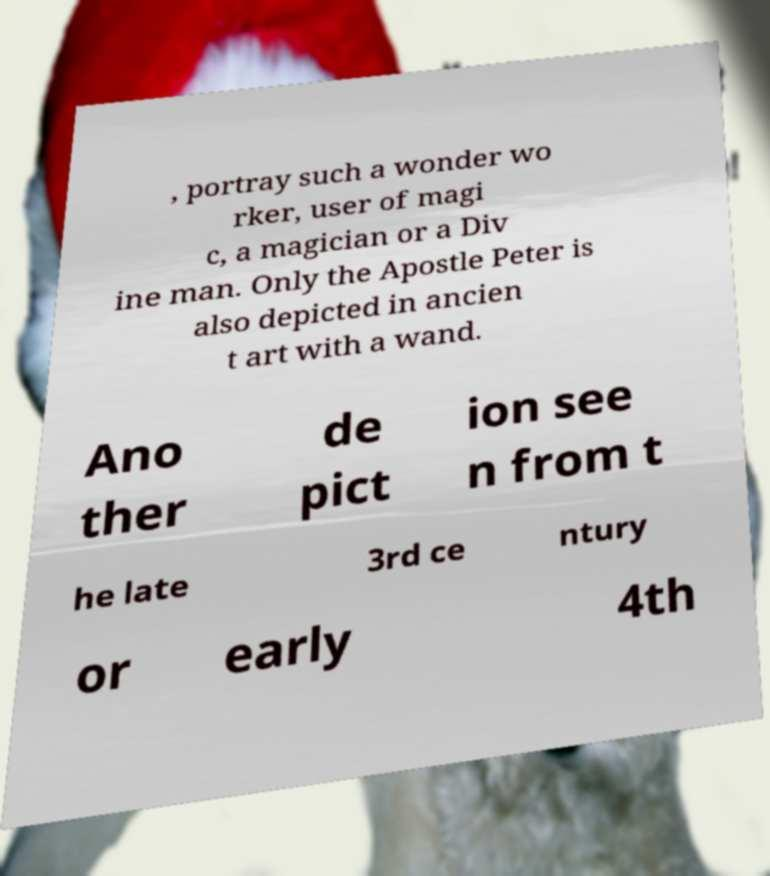I need the written content from this picture converted into text. Can you do that? , portray such a wonder wo rker, user of magi c, a magician or a Div ine man. Only the Apostle Peter is also depicted in ancien t art with a wand. Ano ther de pict ion see n from t he late 3rd ce ntury or early 4th 